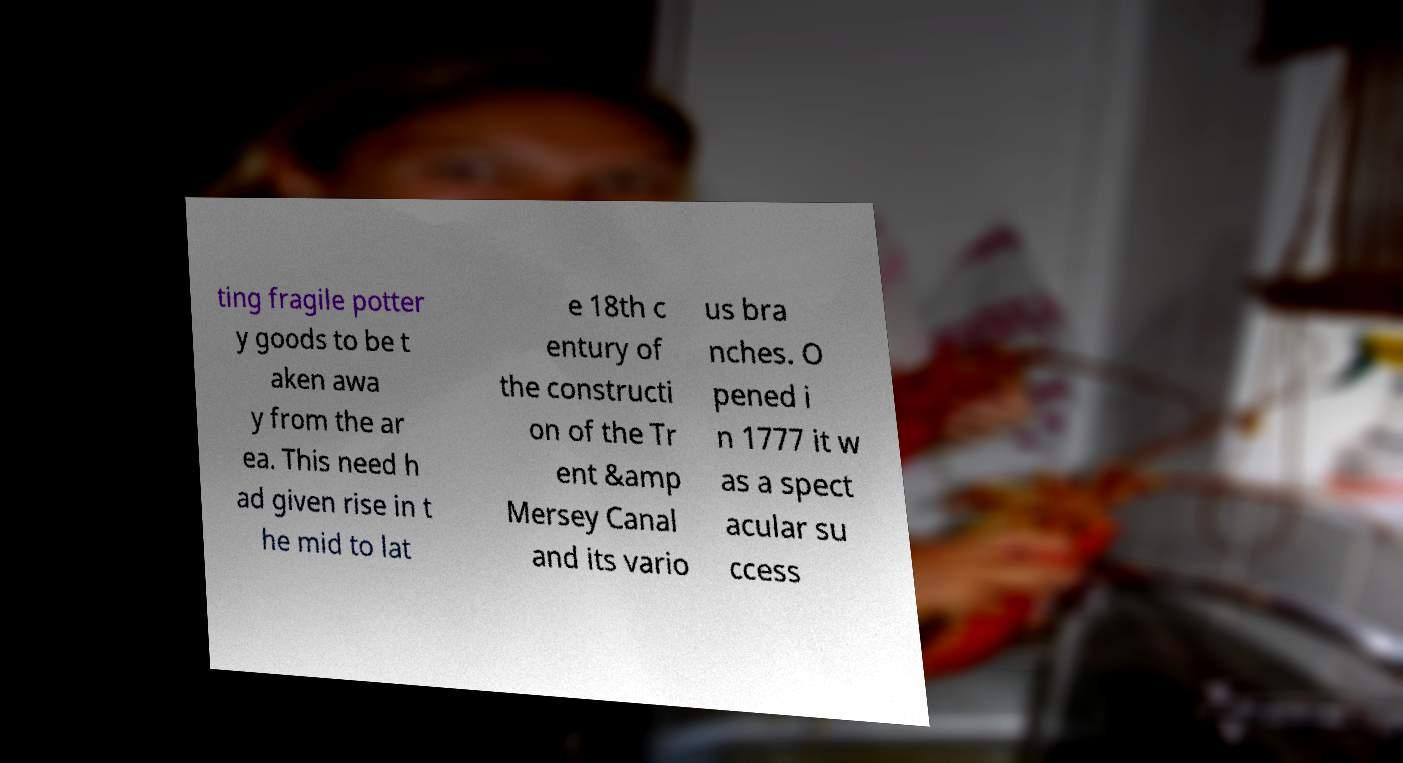Can you read and provide the text displayed in the image?This photo seems to have some interesting text. Can you extract and type it out for me? ting fragile potter y goods to be t aken awa y from the ar ea. This need h ad given rise in t he mid to lat e 18th c entury of the constructi on of the Tr ent &amp Mersey Canal and its vario us bra nches. O pened i n 1777 it w as a spect acular su ccess 